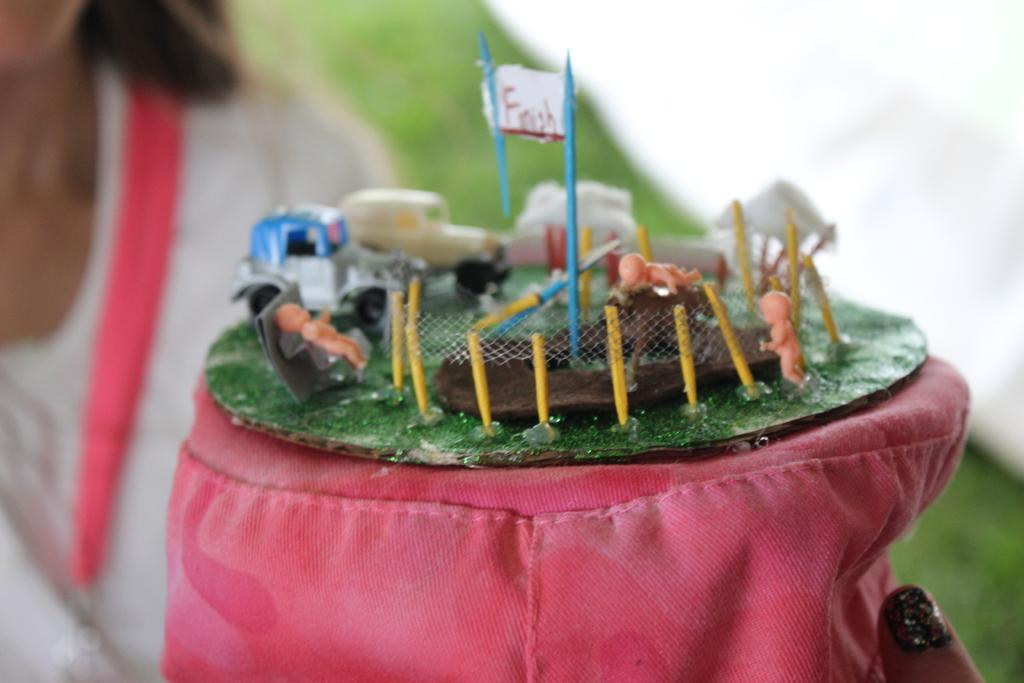What is the main subject in the center of the image? There is a toy in the center of the image. Can you describe anything in the background of the image? There is a person in the background of the image. What type of tent can be seen near the harbor in the image? There is no tent or harbor present in the image; it only features a toy and a person in the background. 